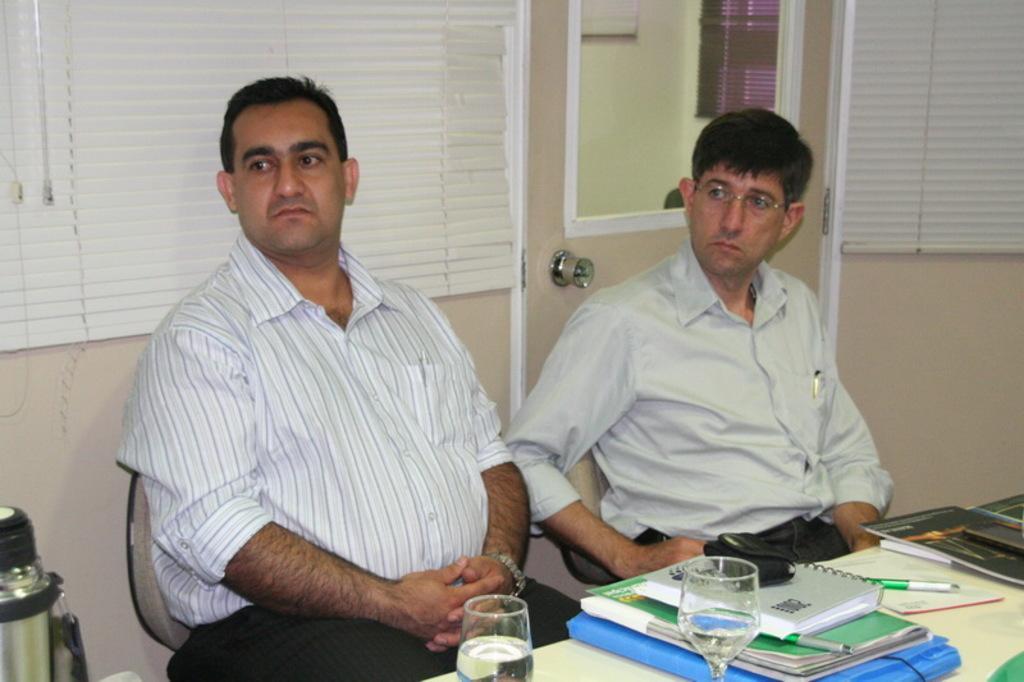Could you give a brief overview of what you see in this image? There are two persons sitting on chairs. In front of them there is a table with books, pens, glasses and a flask. On the top of the book there is a camera pouch. In the back there is a wall. Also there are curtains and a mirror. 